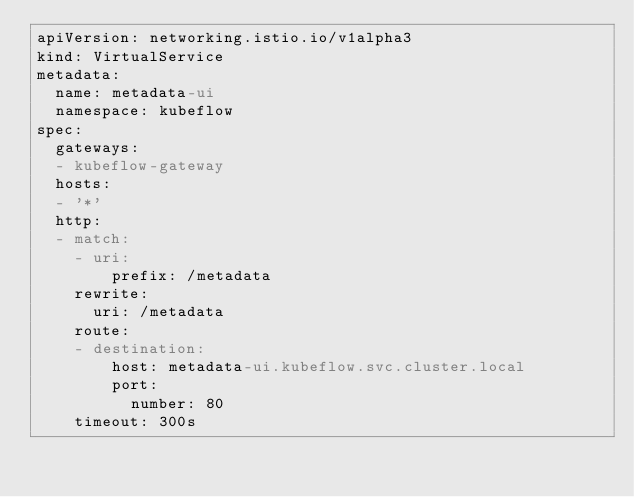Convert code to text. <code><loc_0><loc_0><loc_500><loc_500><_YAML_>apiVersion: networking.istio.io/v1alpha3
kind: VirtualService
metadata:
  name: metadata-ui
  namespace: kubeflow
spec:
  gateways:
  - kubeflow-gateway
  hosts:
  - '*'
  http:
  - match:
    - uri:
        prefix: /metadata
    rewrite:
      uri: /metadata
    route:
    - destination:
        host: metadata-ui.kubeflow.svc.cluster.local
        port:
          number: 80
    timeout: 300s
</code> 